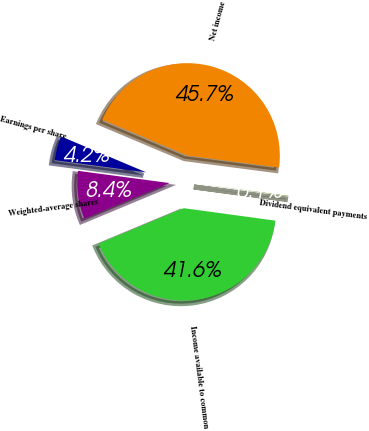Convert chart. <chart><loc_0><loc_0><loc_500><loc_500><pie_chart><fcel>Net income<fcel>Dividend equivalent payments<fcel>Income available to common<fcel>Weighted-average shares<fcel>Earnings per share<nl><fcel>45.71%<fcel>0.09%<fcel>41.56%<fcel>8.4%<fcel>4.24%<nl></chart> 